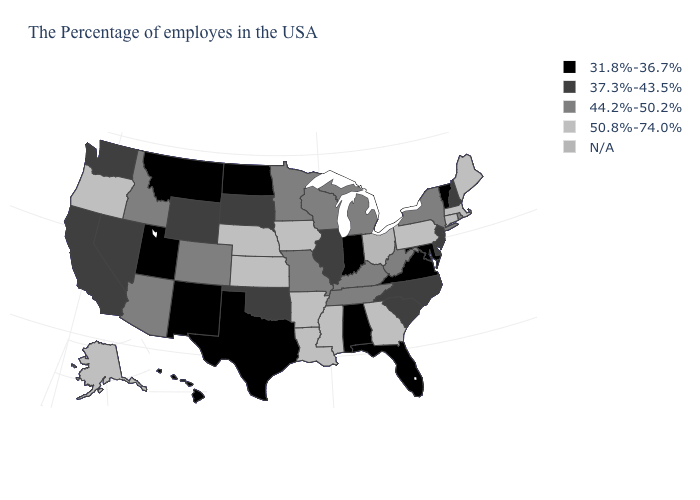What is the value of Wisconsin?
Write a very short answer. 44.2%-50.2%. What is the value of Arizona?
Keep it brief. 44.2%-50.2%. What is the value of Iowa?
Quick response, please. 50.8%-74.0%. Among the states that border New Jersey , which have the highest value?
Concise answer only. Pennsylvania. Name the states that have a value in the range 44.2%-50.2%?
Quick response, please. Rhode Island, New York, West Virginia, Michigan, Kentucky, Tennessee, Wisconsin, Missouri, Minnesota, Colorado, Arizona, Idaho. Among the states that border Iowa , does South Dakota have the highest value?
Short answer required. No. What is the lowest value in the MidWest?
Quick response, please. 31.8%-36.7%. What is the value of Indiana?
Be succinct. 31.8%-36.7%. Name the states that have a value in the range 37.3%-43.5%?
Keep it brief. New Hampshire, New Jersey, Delaware, North Carolina, South Carolina, Illinois, Oklahoma, South Dakota, Wyoming, Nevada, California, Washington. Name the states that have a value in the range 37.3%-43.5%?
Concise answer only. New Hampshire, New Jersey, Delaware, North Carolina, South Carolina, Illinois, Oklahoma, South Dakota, Wyoming, Nevada, California, Washington. Does Maine have the highest value in the Northeast?
Keep it brief. Yes. What is the value of Wisconsin?
Answer briefly. 44.2%-50.2%. Does Minnesota have the lowest value in the USA?
Be succinct. No. Name the states that have a value in the range N/A?
Write a very short answer. Ohio. 